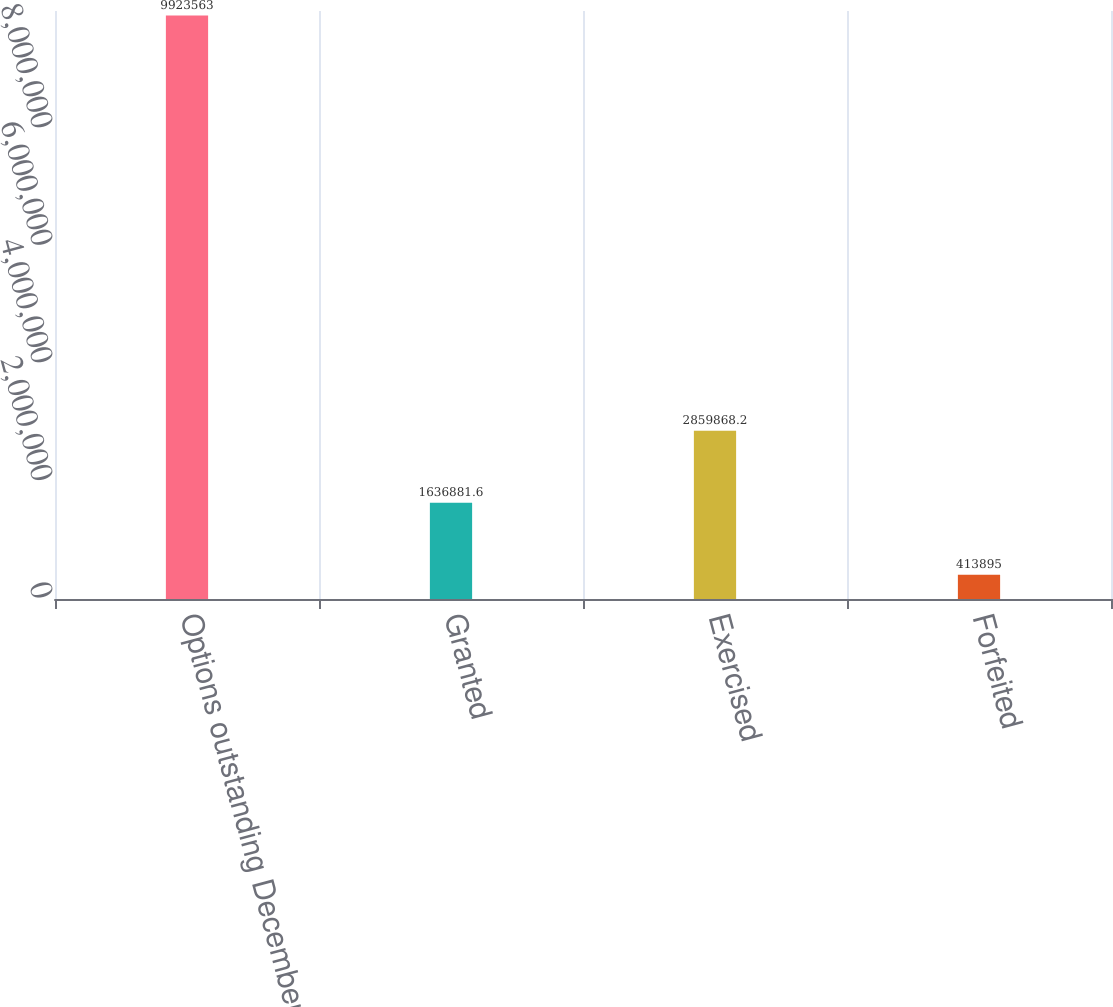<chart> <loc_0><loc_0><loc_500><loc_500><bar_chart><fcel>Options outstanding December<fcel>Granted<fcel>Exercised<fcel>Forfeited<nl><fcel>9.92356e+06<fcel>1.63688e+06<fcel>2.85987e+06<fcel>413895<nl></chart> 